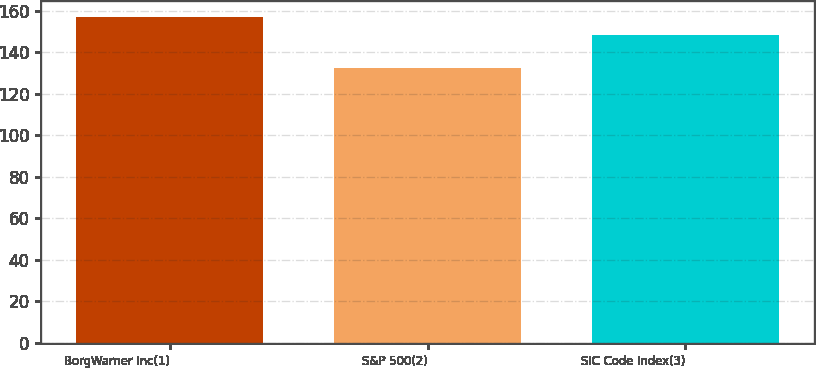<chart> <loc_0><loc_0><loc_500><loc_500><bar_chart><fcel>BorgWarner Inc(1)<fcel>S&P 500(2)<fcel>SIC Code Index(3)<nl><fcel>156.91<fcel>132.39<fcel>148.42<nl></chart> 